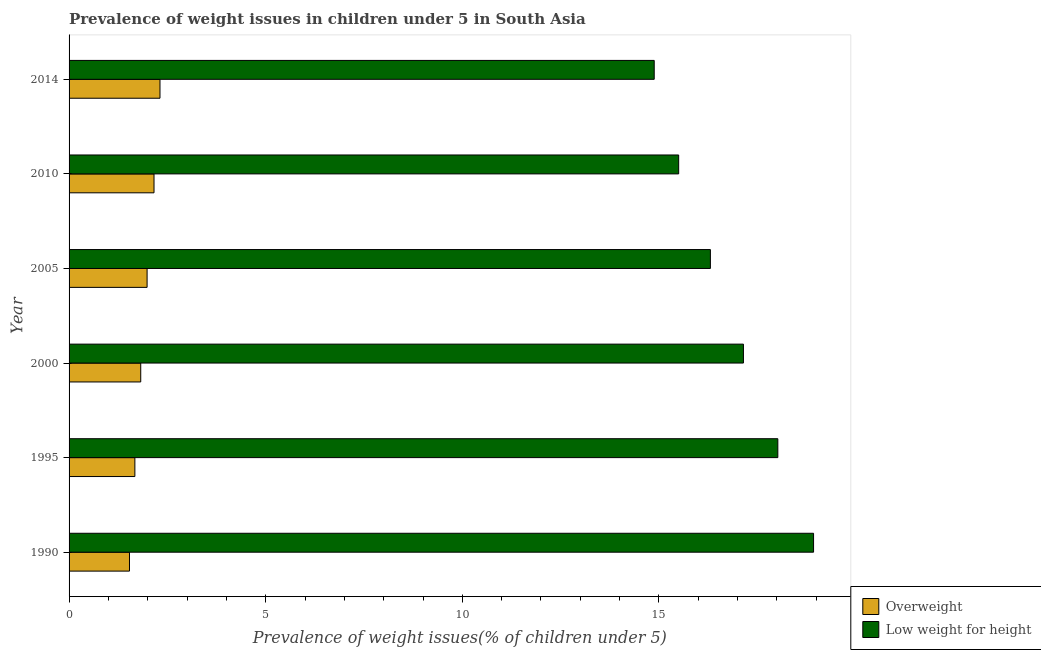How many different coloured bars are there?
Your answer should be compact. 2. How many groups of bars are there?
Provide a succinct answer. 6. Are the number of bars per tick equal to the number of legend labels?
Offer a terse response. Yes. Are the number of bars on each tick of the Y-axis equal?
Offer a terse response. Yes. How many bars are there on the 3rd tick from the top?
Make the answer very short. 2. What is the label of the 1st group of bars from the top?
Offer a very short reply. 2014. In how many cases, is the number of bars for a given year not equal to the number of legend labels?
Your response must be concise. 0. What is the percentage of overweight children in 2000?
Give a very brief answer. 1.82. Across all years, what is the maximum percentage of underweight children?
Give a very brief answer. 18.93. Across all years, what is the minimum percentage of underweight children?
Provide a succinct answer. 14.88. In which year was the percentage of underweight children maximum?
Your response must be concise. 1990. What is the total percentage of underweight children in the graph?
Offer a very short reply. 100.79. What is the difference between the percentage of overweight children in 2000 and that in 2005?
Ensure brevity in your answer.  -0.16. What is the difference between the percentage of underweight children in 1995 and the percentage of overweight children in 2010?
Ensure brevity in your answer.  15.86. What is the average percentage of underweight children per year?
Give a very brief answer. 16.8. In the year 1990, what is the difference between the percentage of underweight children and percentage of overweight children?
Your answer should be compact. 17.39. In how many years, is the percentage of underweight children greater than 10 %?
Provide a short and direct response. 6. What is the ratio of the percentage of underweight children in 1990 to that in 2010?
Provide a succinct answer. 1.22. What is the difference between the highest and the second highest percentage of overweight children?
Keep it short and to the point. 0.15. What is the difference between the highest and the lowest percentage of overweight children?
Provide a succinct answer. 0.78. Is the sum of the percentage of overweight children in 1995 and 2005 greater than the maximum percentage of underweight children across all years?
Give a very brief answer. No. What does the 1st bar from the top in 2000 represents?
Keep it short and to the point. Low weight for height. What does the 1st bar from the bottom in 2014 represents?
Provide a short and direct response. Overweight. How many bars are there?
Your answer should be very brief. 12. Are all the bars in the graph horizontal?
Make the answer very short. Yes. How many years are there in the graph?
Your answer should be compact. 6. Are the values on the major ticks of X-axis written in scientific E-notation?
Give a very brief answer. No. Does the graph contain any zero values?
Your answer should be compact. No. Where does the legend appear in the graph?
Make the answer very short. Bottom right. How are the legend labels stacked?
Your answer should be very brief. Vertical. What is the title of the graph?
Offer a very short reply. Prevalence of weight issues in children under 5 in South Asia. What is the label or title of the X-axis?
Your response must be concise. Prevalence of weight issues(% of children under 5). What is the Prevalence of weight issues(% of children under 5) in Overweight in 1990?
Ensure brevity in your answer.  1.54. What is the Prevalence of weight issues(% of children under 5) of Low weight for height in 1990?
Provide a succinct answer. 18.93. What is the Prevalence of weight issues(% of children under 5) in Overweight in 1995?
Your response must be concise. 1.67. What is the Prevalence of weight issues(% of children under 5) in Low weight for height in 1995?
Make the answer very short. 18.02. What is the Prevalence of weight issues(% of children under 5) in Overweight in 2000?
Your response must be concise. 1.82. What is the Prevalence of weight issues(% of children under 5) in Low weight for height in 2000?
Offer a terse response. 17.15. What is the Prevalence of weight issues(% of children under 5) in Overweight in 2005?
Keep it short and to the point. 1.98. What is the Prevalence of weight issues(% of children under 5) in Low weight for height in 2005?
Give a very brief answer. 16.31. What is the Prevalence of weight issues(% of children under 5) of Overweight in 2010?
Your answer should be compact. 2.16. What is the Prevalence of weight issues(% of children under 5) in Low weight for height in 2010?
Ensure brevity in your answer.  15.5. What is the Prevalence of weight issues(% of children under 5) of Overweight in 2014?
Ensure brevity in your answer.  2.31. What is the Prevalence of weight issues(% of children under 5) of Low weight for height in 2014?
Ensure brevity in your answer.  14.88. Across all years, what is the maximum Prevalence of weight issues(% of children under 5) in Overweight?
Keep it short and to the point. 2.31. Across all years, what is the maximum Prevalence of weight issues(% of children under 5) of Low weight for height?
Make the answer very short. 18.93. Across all years, what is the minimum Prevalence of weight issues(% of children under 5) of Overweight?
Your answer should be very brief. 1.54. Across all years, what is the minimum Prevalence of weight issues(% of children under 5) in Low weight for height?
Your answer should be compact. 14.88. What is the total Prevalence of weight issues(% of children under 5) in Overweight in the graph?
Your answer should be very brief. 11.49. What is the total Prevalence of weight issues(% of children under 5) in Low weight for height in the graph?
Offer a terse response. 100.79. What is the difference between the Prevalence of weight issues(% of children under 5) in Overweight in 1990 and that in 1995?
Offer a terse response. -0.14. What is the difference between the Prevalence of weight issues(% of children under 5) in Low weight for height in 1990 and that in 1995?
Give a very brief answer. 0.91. What is the difference between the Prevalence of weight issues(% of children under 5) of Overweight in 1990 and that in 2000?
Offer a very short reply. -0.29. What is the difference between the Prevalence of weight issues(% of children under 5) in Low weight for height in 1990 and that in 2000?
Give a very brief answer. 1.78. What is the difference between the Prevalence of weight issues(% of children under 5) of Overweight in 1990 and that in 2005?
Give a very brief answer. -0.45. What is the difference between the Prevalence of weight issues(% of children under 5) in Low weight for height in 1990 and that in 2005?
Provide a short and direct response. 2.62. What is the difference between the Prevalence of weight issues(% of children under 5) in Overweight in 1990 and that in 2010?
Provide a succinct answer. -0.62. What is the difference between the Prevalence of weight issues(% of children under 5) of Low weight for height in 1990 and that in 2010?
Your answer should be compact. 3.43. What is the difference between the Prevalence of weight issues(% of children under 5) in Overweight in 1990 and that in 2014?
Your answer should be compact. -0.78. What is the difference between the Prevalence of weight issues(% of children under 5) of Low weight for height in 1990 and that in 2014?
Your answer should be compact. 4.05. What is the difference between the Prevalence of weight issues(% of children under 5) of Overweight in 1995 and that in 2000?
Your response must be concise. -0.15. What is the difference between the Prevalence of weight issues(% of children under 5) of Low weight for height in 1995 and that in 2000?
Give a very brief answer. 0.87. What is the difference between the Prevalence of weight issues(% of children under 5) in Overweight in 1995 and that in 2005?
Give a very brief answer. -0.31. What is the difference between the Prevalence of weight issues(% of children under 5) in Low weight for height in 1995 and that in 2005?
Your answer should be very brief. 1.71. What is the difference between the Prevalence of weight issues(% of children under 5) in Overweight in 1995 and that in 2010?
Your response must be concise. -0.49. What is the difference between the Prevalence of weight issues(% of children under 5) of Low weight for height in 1995 and that in 2010?
Your answer should be compact. 2.52. What is the difference between the Prevalence of weight issues(% of children under 5) of Overweight in 1995 and that in 2014?
Ensure brevity in your answer.  -0.64. What is the difference between the Prevalence of weight issues(% of children under 5) of Low weight for height in 1995 and that in 2014?
Your answer should be compact. 3.14. What is the difference between the Prevalence of weight issues(% of children under 5) in Overweight in 2000 and that in 2005?
Your answer should be very brief. -0.16. What is the difference between the Prevalence of weight issues(% of children under 5) of Low weight for height in 2000 and that in 2005?
Provide a short and direct response. 0.84. What is the difference between the Prevalence of weight issues(% of children under 5) of Overweight in 2000 and that in 2010?
Give a very brief answer. -0.34. What is the difference between the Prevalence of weight issues(% of children under 5) of Low weight for height in 2000 and that in 2010?
Your answer should be compact. 1.65. What is the difference between the Prevalence of weight issues(% of children under 5) of Overweight in 2000 and that in 2014?
Make the answer very short. -0.49. What is the difference between the Prevalence of weight issues(% of children under 5) in Low weight for height in 2000 and that in 2014?
Offer a terse response. 2.27. What is the difference between the Prevalence of weight issues(% of children under 5) of Overweight in 2005 and that in 2010?
Provide a succinct answer. -0.18. What is the difference between the Prevalence of weight issues(% of children under 5) in Low weight for height in 2005 and that in 2010?
Your response must be concise. 0.81. What is the difference between the Prevalence of weight issues(% of children under 5) in Overweight in 2005 and that in 2014?
Your answer should be compact. -0.33. What is the difference between the Prevalence of weight issues(% of children under 5) in Low weight for height in 2005 and that in 2014?
Make the answer very short. 1.43. What is the difference between the Prevalence of weight issues(% of children under 5) in Overweight in 2010 and that in 2014?
Make the answer very short. -0.15. What is the difference between the Prevalence of weight issues(% of children under 5) in Low weight for height in 2010 and that in 2014?
Offer a terse response. 0.62. What is the difference between the Prevalence of weight issues(% of children under 5) of Overweight in 1990 and the Prevalence of weight issues(% of children under 5) of Low weight for height in 1995?
Provide a short and direct response. -16.49. What is the difference between the Prevalence of weight issues(% of children under 5) in Overweight in 1990 and the Prevalence of weight issues(% of children under 5) in Low weight for height in 2000?
Offer a terse response. -15.61. What is the difference between the Prevalence of weight issues(% of children under 5) of Overweight in 1990 and the Prevalence of weight issues(% of children under 5) of Low weight for height in 2005?
Your answer should be compact. -14.77. What is the difference between the Prevalence of weight issues(% of children under 5) of Overweight in 1990 and the Prevalence of weight issues(% of children under 5) of Low weight for height in 2010?
Provide a short and direct response. -13.97. What is the difference between the Prevalence of weight issues(% of children under 5) of Overweight in 1990 and the Prevalence of weight issues(% of children under 5) of Low weight for height in 2014?
Give a very brief answer. -13.34. What is the difference between the Prevalence of weight issues(% of children under 5) in Overweight in 1995 and the Prevalence of weight issues(% of children under 5) in Low weight for height in 2000?
Offer a terse response. -15.48. What is the difference between the Prevalence of weight issues(% of children under 5) of Overweight in 1995 and the Prevalence of weight issues(% of children under 5) of Low weight for height in 2005?
Your response must be concise. -14.63. What is the difference between the Prevalence of weight issues(% of children under 5) in Overweight in 1995 and the Prevalence of weight issues(% of children under 5) in Low weight for height in 2010?
Make the answer very short. -13.83. What is the difference between the Prevalence of weight issues(% of children under 5) in Overweight in 1995 and the Prevalence of weight issues(% of children under 5) in Low weight for height in 2014?
Offer a very short reply. -13.21. What is the difference between the Prevalence of weight issues(% of children under 5) of Overweight in 2000 and the Prevalence of weight issues(% of children under 5) of Low weight for height in 2005?
Provide a succinct answer. -14.49. What is the difference between the Prevalence of weight issues(% of children under 5) of Overweight in 2000 and the Prevalence of weight issues(% of children under 5) of Low weight for height in 2010?
Provide a short and direct response. -13.68. What is the difference between the Prevalence of weight issues(% of children under 5) in Overweight in 2000 and the Prevalence of weight issues(% of children under 5) in Low weight for height in 2014?
Your answer should be compact. -13.06. What is the difference between the Prevalence of weight issues(% of children under 5) of Overweight in 2005 and the Prevalence of weight issues(% of children under 5) of Low weight for height in 2010?
Provide a succinct answer. -13.52. What is the difference between the Prevalence of weight issues(% of children under 5) in Overweight in 2005 and the Prevalence of weight issues(% of children under 5) in Low weight for height in 2014?
Offer a very short reply. -12.9. What is the difference between the Prevalence of weight issues(% of children under 5) in Overweight in 2010 and the Prevalence of weight issues(% of children under 5) in Low weight for height in 2014?
Your response must be concise. -12.72. What is the average Prevalence of weight issues(% of children under 5) of Overweight per year?
Provide a succinct answer. 1.91. What is the average Prevalence of weight issues(% of children under 5) of Low weight for height per year?
Your response must be concise. 16.8. In the year 1990, what is the difference between the Prevalence of weight issues(% of children under 5) in Overweight and Prevalence of weight issues(% of children under 5) in Low weight for height?
Keep it short and to the point. -17.4. In the year 1995, what is the difference between the Prevalence of weight issues(% of children under 5) of Overweight and Prevalence of weight issues(% of children under 5) of Low weight for height?
Give a very brief answer. -16.35. In the year 2000, what is the difference between the Prevalence of weight issues(% of children under 5) in Overweight and Prevalence of weight issues(% of children under 5) in Low weight for height?
Provide a succinct answer. -15.33. In the year 2005, what is the difference between the Prevalence of weight issues(% of children under 5) of Overweight and Prevalence of weight issues(% of children under 5) of Low weight for height?
Provide a short and direct response. -14.32. In the year 2010, what is the difference between the Prevalence of weight issues(% of children under 5) of Overweight and Prevalence of weight issues(% of children under 5) of Low weight for height?
Ensure brevity in your answer.  -13.34. In the year 2014, what is the difference between the Prevalence of weight issues(% of children under 5) in Overweight and Prevalence of weight issues(% of children under 5) in Low weight for height?
Ensure brevity in your answer.  -12.57. What is the ratio of the Prevalence of weight issues(% of children under 5) of Overweight in 1990 to that in 1995?
Provide a short and direct response. 0.92. What is the ratio of the Prevalence of weight issues(% of children under 5) in Low weight for height in 1990 to that in 1995?
Your answer should be very brief. 1.05. What is the ratio of the Prevalence of weight issues(% of children under 5) of Overweight in 1990 to that in 2000?
Give a very brief answer. 0.84. What is the ratio of the Prevalence of weight issues(% of children under 5) of Low weight for height in 1990 to that in 2000?
Offer a very short reply. 1.1. What is the ratio of the Prevalence of weight issues(% of children under 5) in Overweight in 1990 to that in 2005?
Ensure brevity in your answer.  0.77. What is the ratio of the Prevalence of weight issues(% of children under 5) in Low weight for height in 1990 to that in 2005?
Offer a very short reply. 1.16. What is the ratio of the Prevalence of weight issues(% of children under 5) in Overweight in 1990 to that in 2010?
Provide a succinct answer. 0.71. What is the ratio of the Prevalence of weight issues(% of children under 5) in Low weight for height in 1990 to that in 2010?
Offer a terse response. 1.22. What is the ratio of the Prevalence of weight issues(% of children under 5) of Overweight in 1990 to that in 2014?
Provide a short and direct response. 0.66. What is the ratio of the Prevalence of weight issues(% of children under 5) of Low weight for height in 1990 to that in 2014?
Keep it short and to the point. 1.27. What is the ratio of the Prevalence of weight issues(% of children under 5) in Overweight in 1995 to that in 2000?
Your response must be concise. 0.92. What is the ratio of the Prevalence of weight issues(% of children under 5) in Low weight for height in 1995 to that in 2000?
Offer a very short reply. 1.05. What is the ratio of the Prevalence of weight issues(% of children under 5) of Overweight in 1995 to that in 2005?
Give a very brief answer. 0.84. What is the ratio of the Prevalence of weight issues(% of children under 5) of Low weight for height in 1995 to that in 2005?
Ensure brevity in your answer.  1.11. What is the ratio of the Prevalence of weight issues(% of children under 5) in Overweight in 1995 to that in 2010?
Your response must be concise. 0.77. What is the ratio of the Prevalence of weight issues(% of children under 5) in Low weight for height in 1995 to that in 2010?
Offer a very short reply. 1.16. What is the ratio of the Prevalence of weight issues(% of children under 5) in Overweight in 1995 to that in 2014?
Make the answer very short. 0.72. What is the ratio of the Prevalence of weight issues(% of children under 5) in Low weight for height in 1995 to that in 2014?
Offer a very short reply. 1.21. What is the ratio of the Prevalence of weight issues(% of children under 5) in Overweight in 2000 to that in 2005?
Your answer should be very brief. 0.92. What is the ratio of the Prevalence of weight issues(% of children under 5) in Low weight for height in 2000 to that in 2005?
Offer a terse response. 1.05. What is the ratio of the Prevalence of weight issues(% of children under 5) in Overweight in 2000 to that in 2010?
Ensure brevity in your answer.  0.84. What is the ratio of the Prevalence of weight issues(% of children under 5) of Low weight for height in 2000 to that in 2010?
Your answer should be very brief. 1.11. What is the ratio of the Prevalence of weight issues(% of children under 5) in Overweight in 2000 to that in 2014?
Your answer should be compact. 0.79. What is the ratio of the Prevalence of weight issues(% of children under 5) in Low weight for height in 2000 to that in 2014?
Make the answer very short. 1.15. What is the ratio of the Prevalence of weight issues(% of children under 5) of Overweight in 2005 to that in 2010?
Offer a terse response. 0.92. What is the ratio of the Prevalence of weight issues(% of children under 5) of Low weight for height in 2005 to that in 2010?
Ensure brevity in your answer.  1.05. What is the ratio of the Prevalence of weight issues(% of children under 5) in Overweight in 2005 to that in 2014?
Your answer should be compact. 0.86. What is the ratio of the Prevalence of weight issues(% of children under 5) in Low weight for height in 2005 to that in 2014?
Provide a short and direct response. 1.1. What is the ratio of the Prevalence of weight issues(% of children under 5) in Overweight in 2010 to that in 2014?
Give a very brief answer. 0.93. What is the ratio of the Prevalence of weight issues(% of children under 5) in Low weight for height in 2010 to that in 2014?
Provide a succinct answer. 1.04. What is the difference between the highest and the second highest Prevalence of weight issues(% of children under 5) in Overweight?
Offer a very short reply. 0.15. What is the difference between the highest and the second highest Prevalence of weight issues(% of children under 5) in Low weight for height?
Ensure brevity in your answer.  0.91. What is the difference between the highest and the lowest Prevalence of weight issues(% of children under 5) in Overweight?
Provide a short and direct response. 0.78. What is the difference between the highest and the lowest Prevalence of weight issues(% of children under 5) in Low weight for height?
Ensure brevity in your answer.  4.05. 